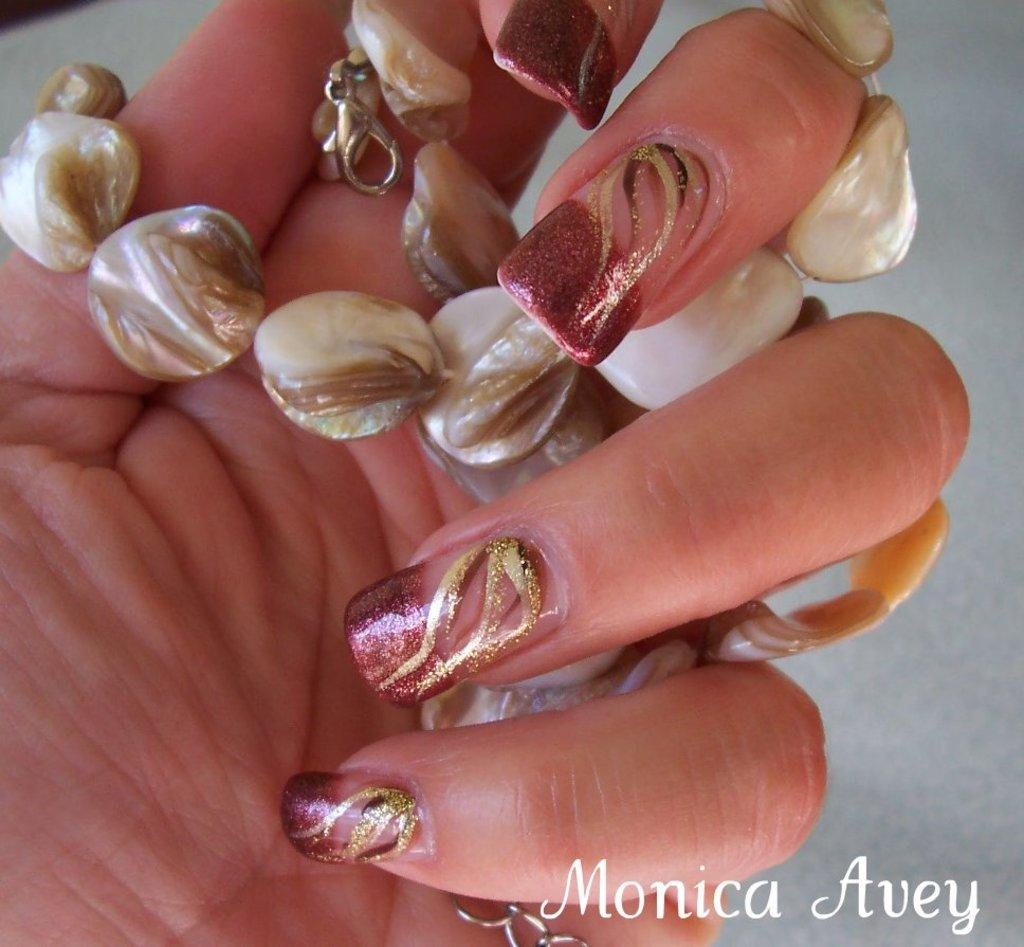Provide a one-sentence caption for the provided image. The nail polish picture is made by Monica Avey. 